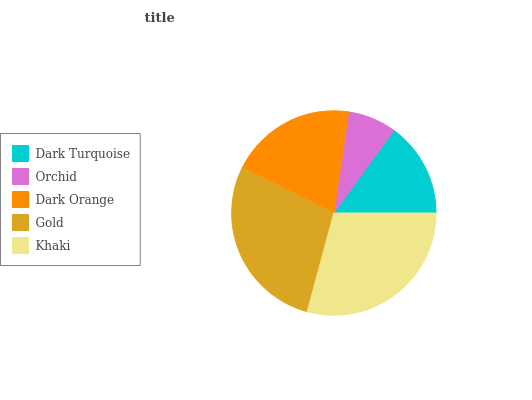Is Orchid the minimum?
Answer yes or no. Yes. Is Khaki the maximum?
Answer yes or no. Yes. Is Dark Orange the minimum?
Answer yes or no. No. Is Dark Orange the maximum?
Answer yes or no. No. Is Dark Orange greater than Orchid?
Answer yes or no. Yes. Is Orchid less than Dark Orange?
Answer yes or no. Yes. Is Orchid greater than Dark Orange?
Answer yes or no. No. Is Dark Orange less than Orchid?
Answer yes or no. No. Is Dark Orange the high median?
Answer yes or no. Yes. Is Dark Orange the low median?
Answer yes or no. Yes. Is Gold the high median?
Answer yes or no. No. Is Orchid the low median?
Answer yes or no. No. 